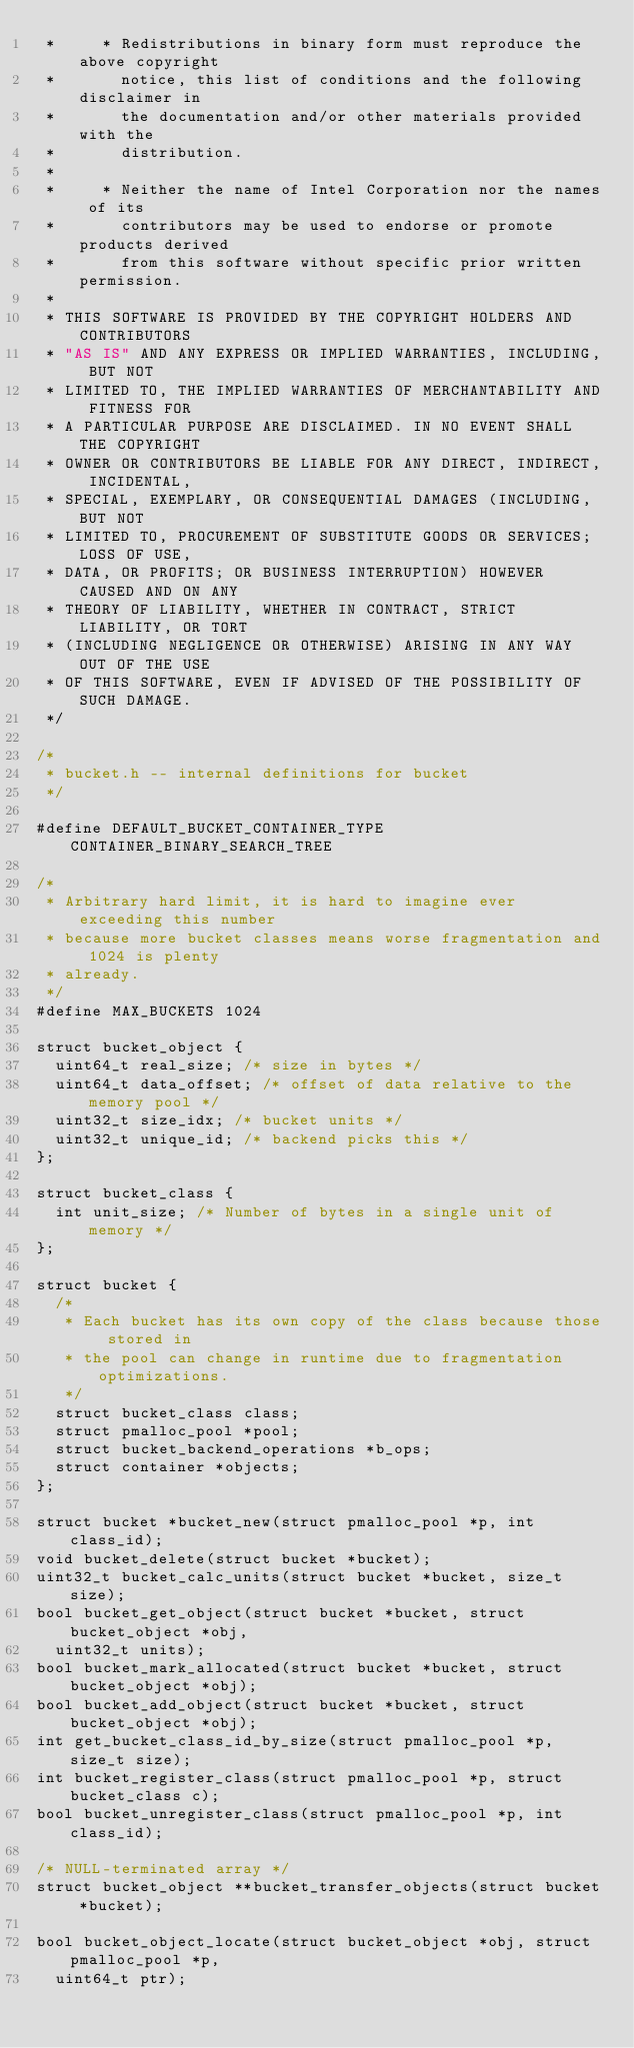<code> <loc_0><loc_0><loc_500><loc_500><_C_> *     * Redistributions in binary form must reproduce the above copyright
 *       notice, this list of conditions and the following disclaimer in
 *       the documentation and/or other materials provided with the
 *       distribution.
 *
 *     * Neither the name of Intel Corporation nor the names of its
 *       contributors may be used to endorse or promote products derived
 *       from this software without specific prior written permission.
 *
 * THIS SOFTWARE IS PROVIDED BY THE COPYRIGHT HOLDERS AND CONTRIBUTORS
 * "AS IS" AND ANY EXPRESS OR IMPLIED WARRANTIES, INCLUDING, BUT NOT
 * LIMITED TO, THE IMPLIED WARRANTIES OF MERCHANTABILITY AND FITNESS FOR
 * A PARTICULAR PURPOSE ARE DISCLAIMED. IN NO EVENT SHALL THE COPYRIGHT
 * OWNER OR CONTRIBUTORS BE LIABLE FOR ANY DIRECT, INDIRECT, INCIDENTAL,
 * SPECIAL, EXEMPLARY, OR CONSEQUENTIAL DAMAGES (INCLUDING, BUT NOT
 * LIMITED TO, PROCUREMENT OF SUBSTITUTE GOODS OR SERVICES; LOSS OF USE,
 * DATA, OR PROFITS; OR BUSINESS INTERRUPTION) HOWEVER CAUSED AND ON ANY
 * THEORY OF LIABILITY, WHETHER IN CONTRACT, STRICT LIABILITY, OR TORT
 * (INCLUDING NEGLIGENCE OR OTHERWISE) ARISING IN ANY WAY OUT OF THE USE
 * OF THIS SOFTWARE, EVEN IF ADVISED OF THE POSSIBILITY OF SUCH DAMAGE.
 */

/*
 * bucket.h -- internal definitions for bucket
 */

#define	DEFAULT_BUCKET_CONTAINER_TYPE CONTAINER_BINARY_SEARCH_TREE

/*
 * Arbitrary hard limit, it is hard to imagine ever exceeding this number
 * because more bucket classes means worse fragmentation and 1024 is plenty
 * already.
 */
#define	MAX_BUCKETS 1024

struct bucket_object {
	uint64_t real_size; /* size in bytes */
	uint64_t data_offset; /* offset of data relative to the memory pool */
	uint32_t size_idx; /* bucket units */
	uint32_t unique_id; /* backend picks this */
};

struct bucket_class {
	int unit_size; /* Number of bytes in a single unit of memory */
};

struct bucket {
	/*
	 * Each bucket has its own copy of the class because those stored in
	 * the pool can change in runtime due to fragmentation optimizations.
	 */
	struct bucket_class class;
	struct pmalloc_pool *pool;
	struct bucket_backend_operations *b_ops;
	struct container *objects;
};

struct bucket *bucket_new(struct pmalloc_pool *p, int class_id);
void bucket_delete(struct bucket *bucket);
uint32_t bucket_calc_units(struct bucket *bucket, size_t size);
bool bucket_get_object(struct bucket *bucket, struct bucket_object *obj,
	uint32_t units);
bool bucket_mark_allocated(struct bucket *bucket, struct bucket_object *obj);
bool bucket_add_object(struct bucket *bucket, struct bucket_object *obj);
int get_bucket_class_id_by_size(struct pmalloc_pool *p, size_t size);
int bucket_register_class(struct pmalloc_pool *p, struct bucket_class c);
bool bucket_unregister_class(struct pmalloc_pool *p, int class_id);

/* NULL-terminated array */
struct bucket_object **bucket_transfer_objects(struct bucket *bucket);

bool bucket_object_locate(struct bucket_object *obj, struct pmalloc_pool *p,
	uint64_t ptr);
</code> 